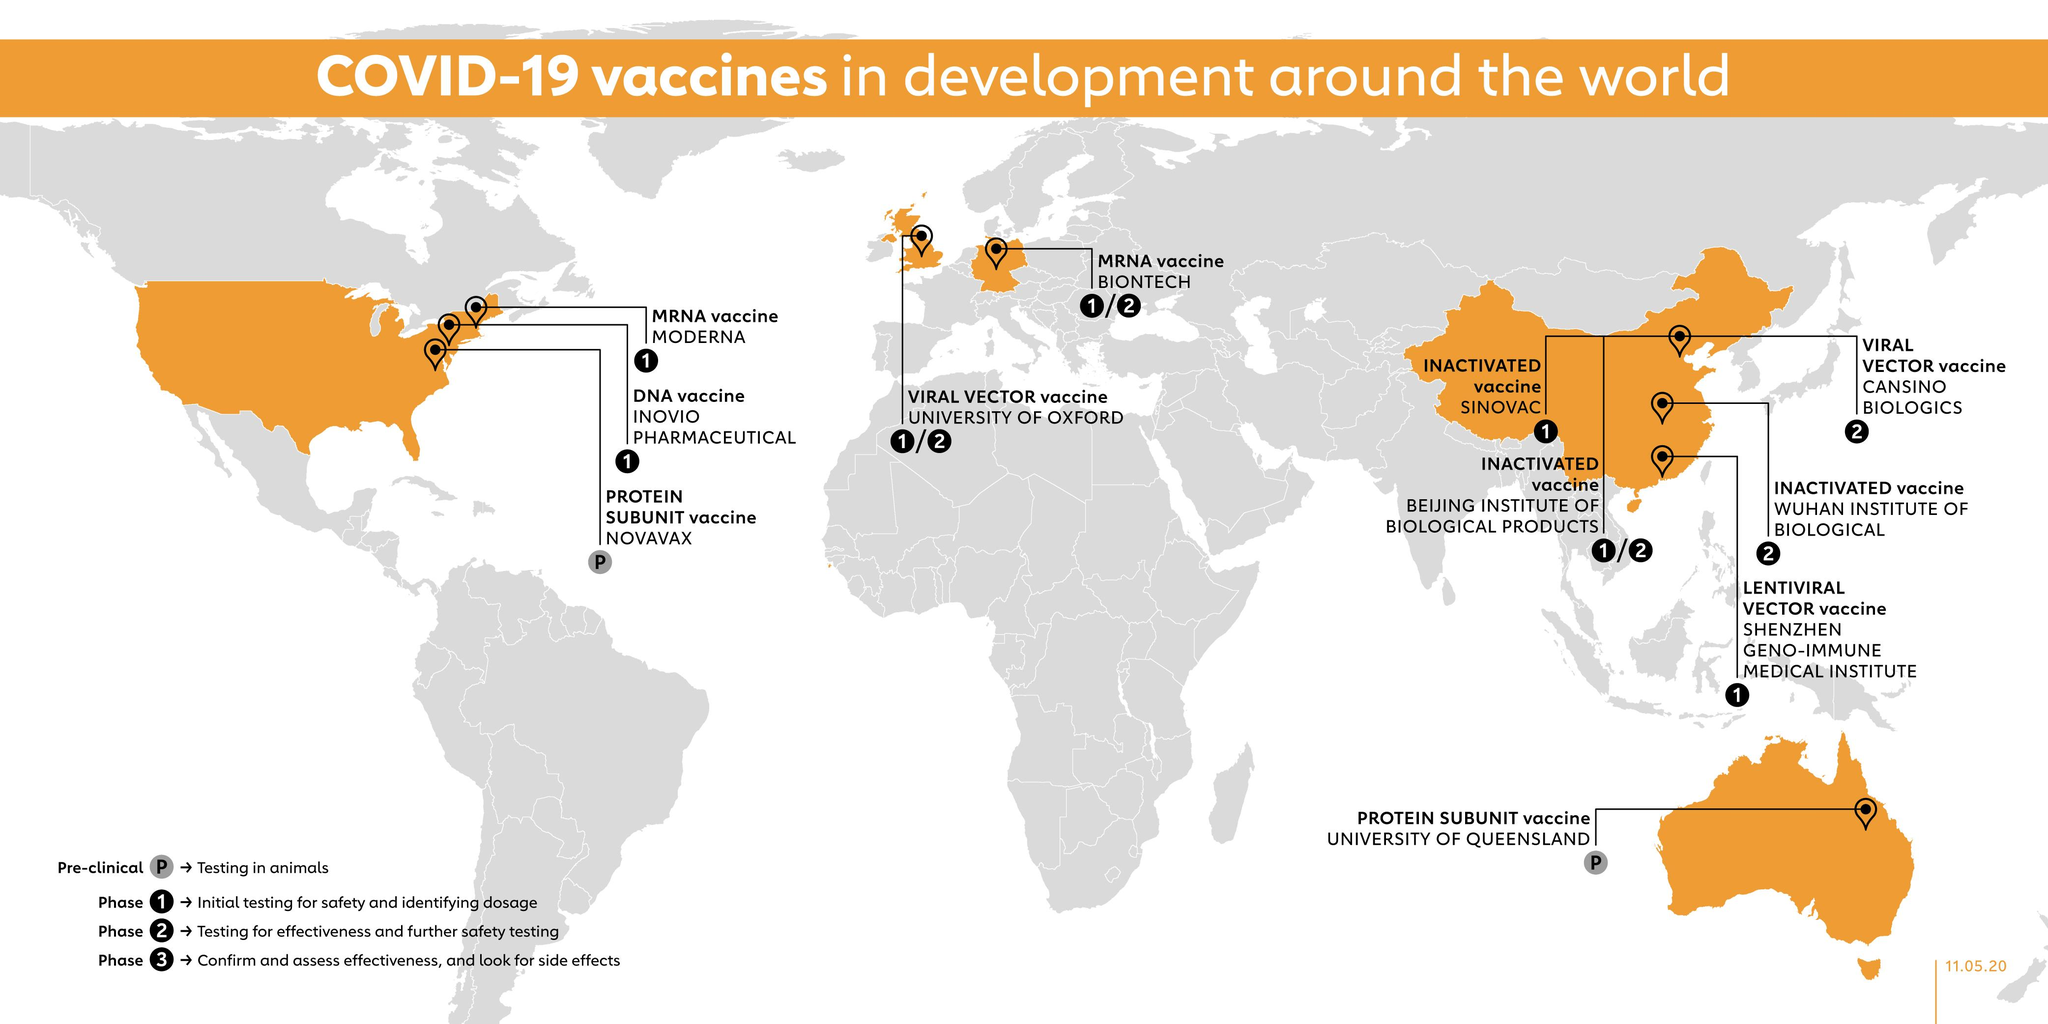Point out several critical features in this image. The pre-clinical trials of the COVID-19 vaccine developed in Australia were conducted at the University of Queensland. The COVID-19 vaccine clinical trials for the viral vector-based vaccine were conducted in the UK, with phase 1 and phase 2 trials performed at the University of Oxford. The MRNA vaccine for COVID-19 has undergone phase 1 and phase 2 clinical trials in Germany, which were conducted by BIONTECH. 